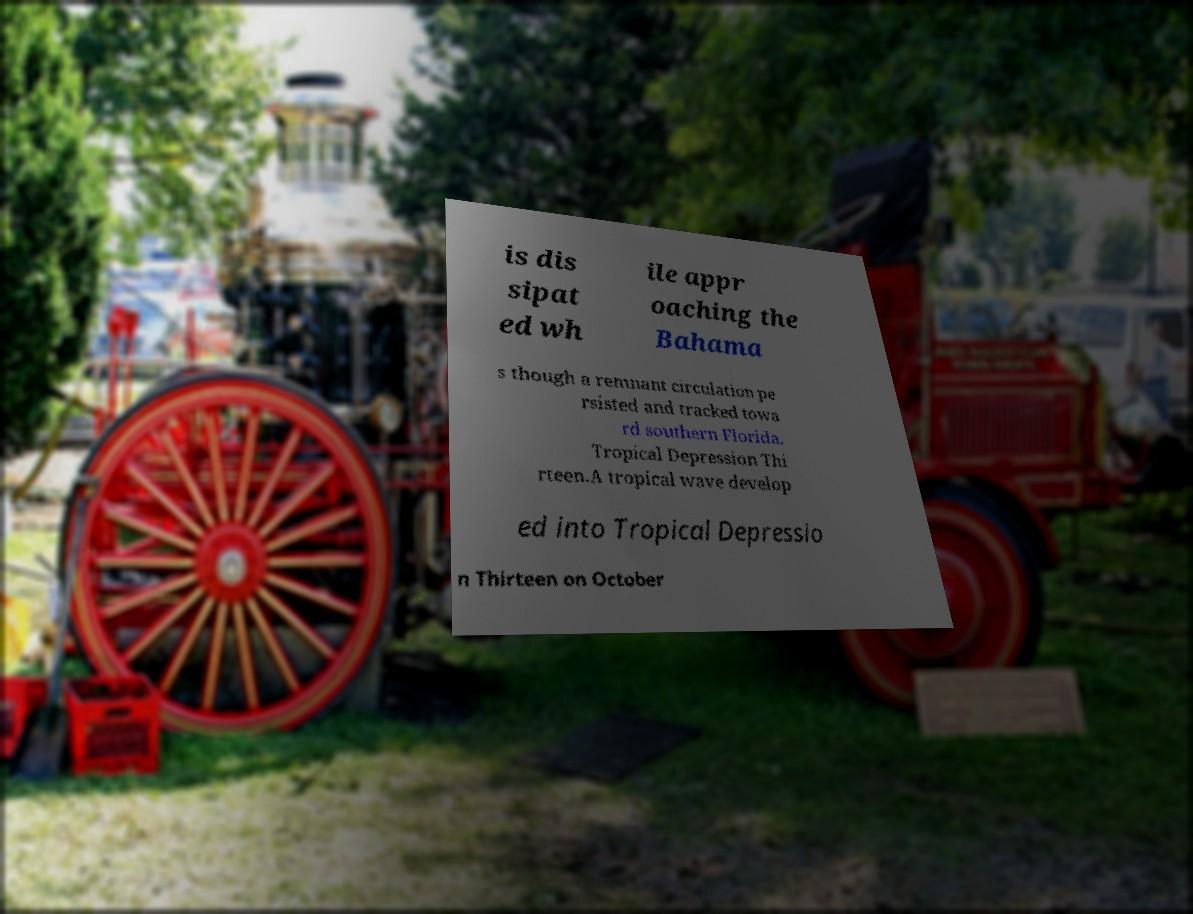I need the written content from this picture converted into text. Can you do that? is dis sipat ed wh ile appr oaching the Bahama s though a remnant circulation pe rsisted and tracked towa rd southern Florida. Tropical Depression Thi rteen.A tropical wave develop ed into Tropical Depressio n Thirteen on October 